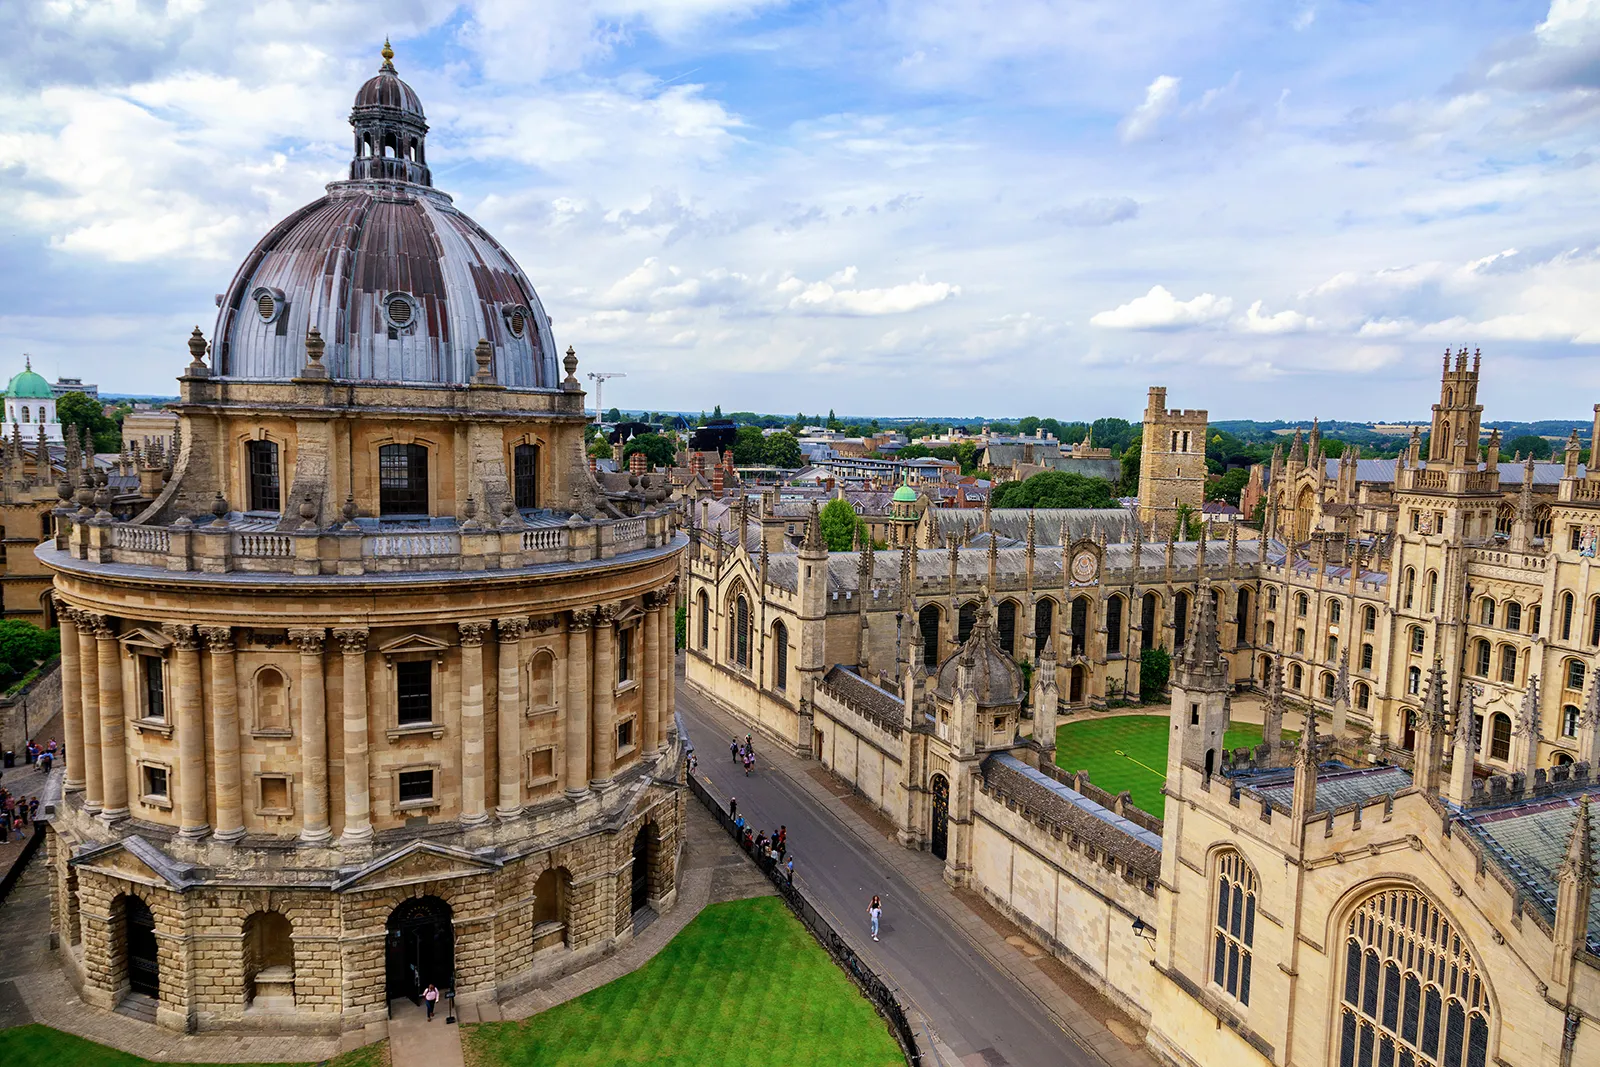Describe a short, casual interaction between two students meeting in front of this building. Two students, Alex and Jamie, meet in front of the Radcliffe Camera. Alex waves and says, 'Hey Jamie, ready for the study session?' Jamie, adjusting their backpack, replies, 'Yeah, just finished a lecture. This place never gets old, huh?' Alex smiles, 'Absolutely, every time I see it, I'm reminded of how lucky we are to study here.' Together, they enter the library, eager to tackle the day's academic challenges. 